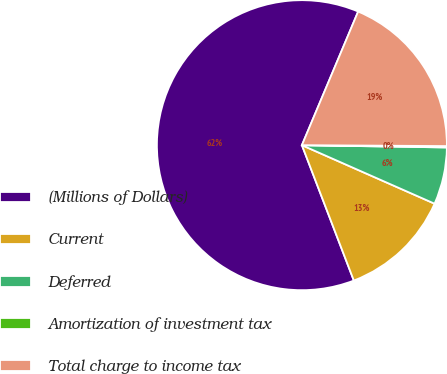<chart> <loc_0><loc_0><loc_500><loc_500><pie_chart><fcel>(Millions of Dollars)<fcel>Current<fcel>Deferred<fcel>Amortization of investment tax<fcel>Total charge to income tax<nl><fcel>62.17%<fcel>12.56%<fcel>6.36%<fcel>0.15%<fcel>18.76%<nl></chart> 